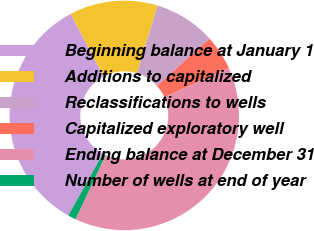Convert chart. <chart><loc_0><loc_0><loc_500><loc_500><pie_chart><fcel>Beginning balance at January 1<fcel>Additions to capitalized<fcel>Reclassifications to wells<fcel>Capitalized exploratory well<fcel>Ending balance at December 31<fcel>Number of wells at end of year<nl><fcel>34.16%<fcel>12.41%<fcel>8.65%<fcel>4.89%<fcel>38.74%<fcel>1.13%<nl></chart> 